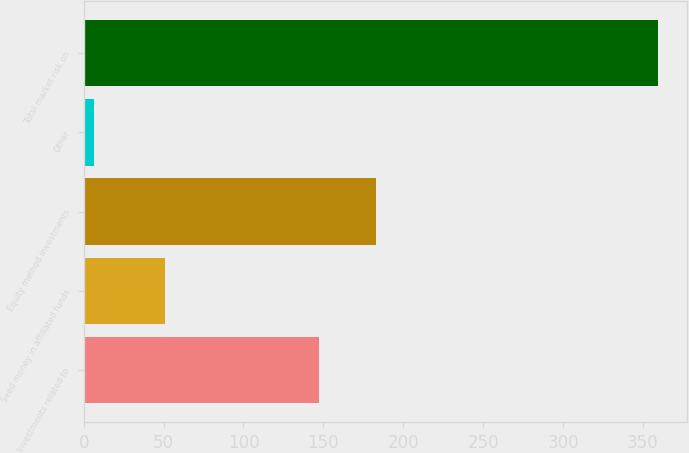Convert chart to OTSL. <chart><loc_0><loc_0><loc_500><loc_500><bar_chart><fcel>Investments related to<fcel>Seed money in affiliated funds<fcel>Equity method investments<fcel>Other<fcel>Total market risk on<nl><fcel>147.5<fcel>50.8<fcel>182.78<fcel>6.6<fcel>359.4<nl></chart> 